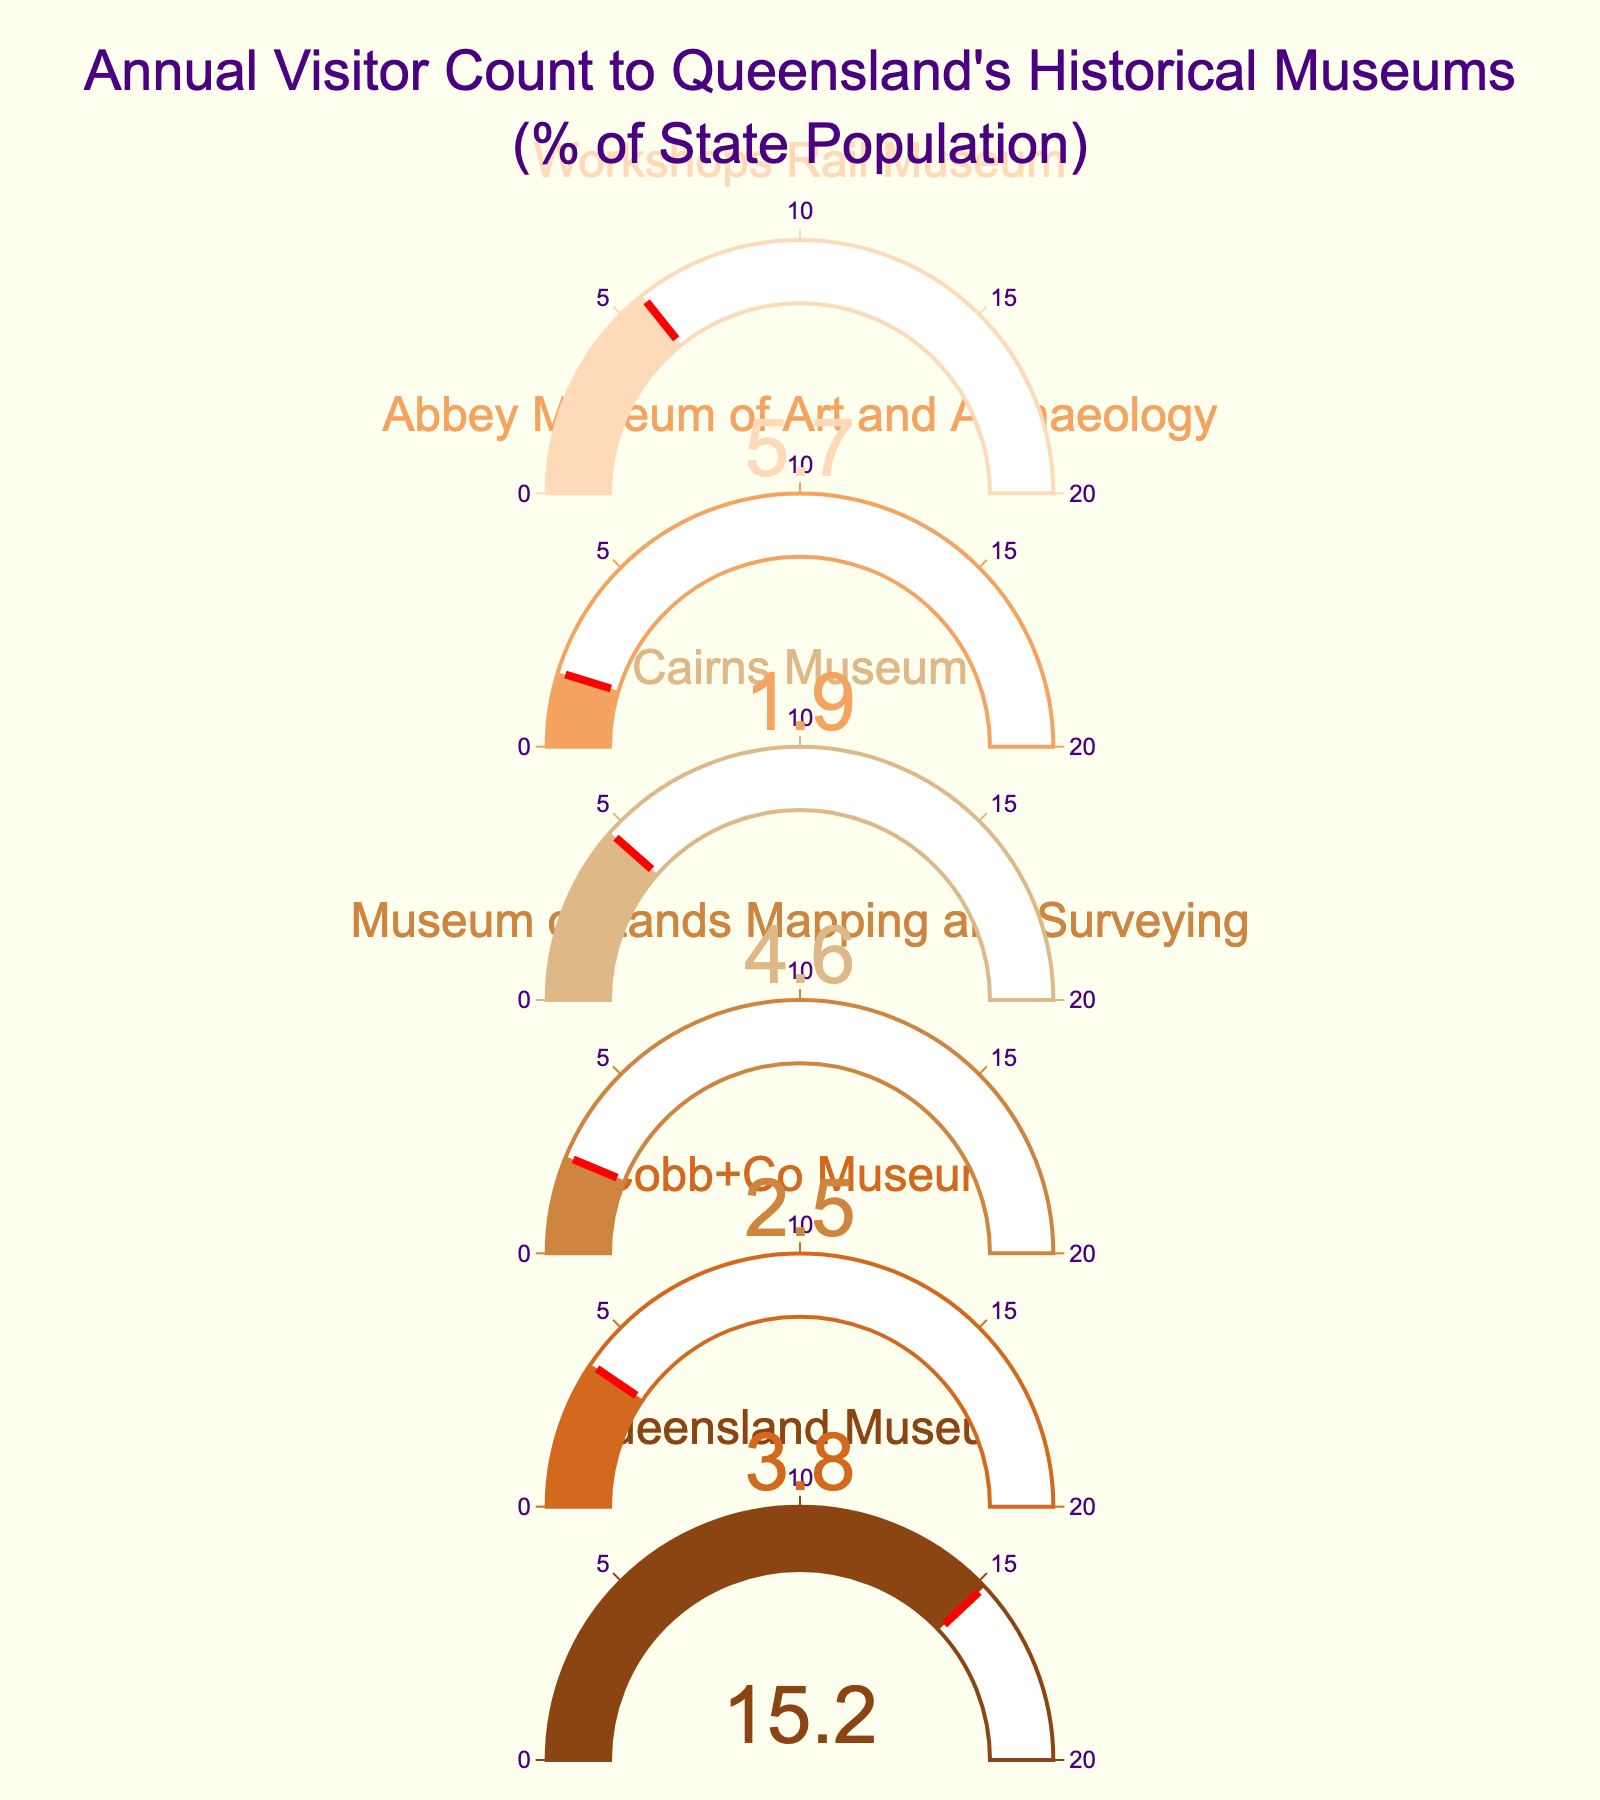What is the highest visitor percentage displayed? The figure shows multiple gauges with visitor percentages for different museums. By checking all values, we see that the highest percentage is for Queensland Museum at 15.2%.
Answer: Queensland Museum How many museums have a visitor percentage greater than 5%? We check the values on each gauge: Queensland Museum (15.2%), Cobb+Co Museum (3.8%), Museum of Lands Mapping and Surveying (2.5%), Cairns Museum (4.6%), Abbey Museum of Art and Archaeology (1.9%), Workshops Rail Museum (5.7%). Only Queensland Museum and Workshops Rail Museum have percentages greater than 5%.
Answer: 2 What is the title of the figure? The title is typically displayed at the top of the figure. It states, “Annual Visitor Count to Queensland's Historical Museums (% of State Population)”.
Answer: Annual Visitor Count to Queensland's Historical Museums (% of State Population) What is the sum of visitor percentages for all museums? Summing the visitor percentages for all museums: 15.2% (Queensland Museum) + 3.8% (Cobb+Co Museum) + 2.5% (Museum of Lands Mapping and Surveying) + 4.6% (Cairns Museum) + 1.9% (Abbey Museum of Art and Archaeology) + 5.7% (Workshops Rail Museum) = 33.7%.
Answer: 33.7% Which museum has the smallest visitor percentage? Checking the smallest value displayed on the gauges, the Abbey Museum of Art and Archaeology has the lowest visitor percentage at 1.9%.
Answer: Abbey Museum of Art and Archaeology What is the average visitor percentage across all museums? The sum of all percentages is 33.7%. There are 6 museums. Average = 33.7 / 6 = 5.6167%.
Answer: 5.62% (rounded to 2 decimal places) What color is used for the Queensland Museum's gauge? The Queensland Museum's gauge is the first one displayed, and it is colored brown.
Answer: Brown Which museum’s visitor percentage is the closest to 5%? Checking all values, Cairns Museum has a visitor percentage of 4.6%, which is the closest to 5%.
Answer: Cairns Museum Is there any museum with an equal to 3.8% visitor percentage? Referring to the gauges, Cobb+Co Museum has exactly 3.8% visitor percentage.
Answer: Cobb+Co Museum What is the visitor percentage difference between Queensland Museum and Cobb+Co Museum? Queensland Museum has 15.2% and Cobb+Co Museum has 3.8%. The difference is 15.2% - 3.8% = 11.4%.
Answer: 11.4% 